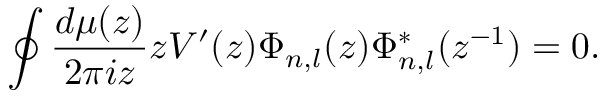<formula> <loc_0><loc_0><loc_500><loc_500>\oint \frac { d \mu ( z ) } { 2 \pi i z } z V ^ { \prime } ( z ) \Phi _ { n , l } ( z ) \Phi _ { n , l } ^ { * } ( z ^ { - 1 } ) = 0 .</formula> 